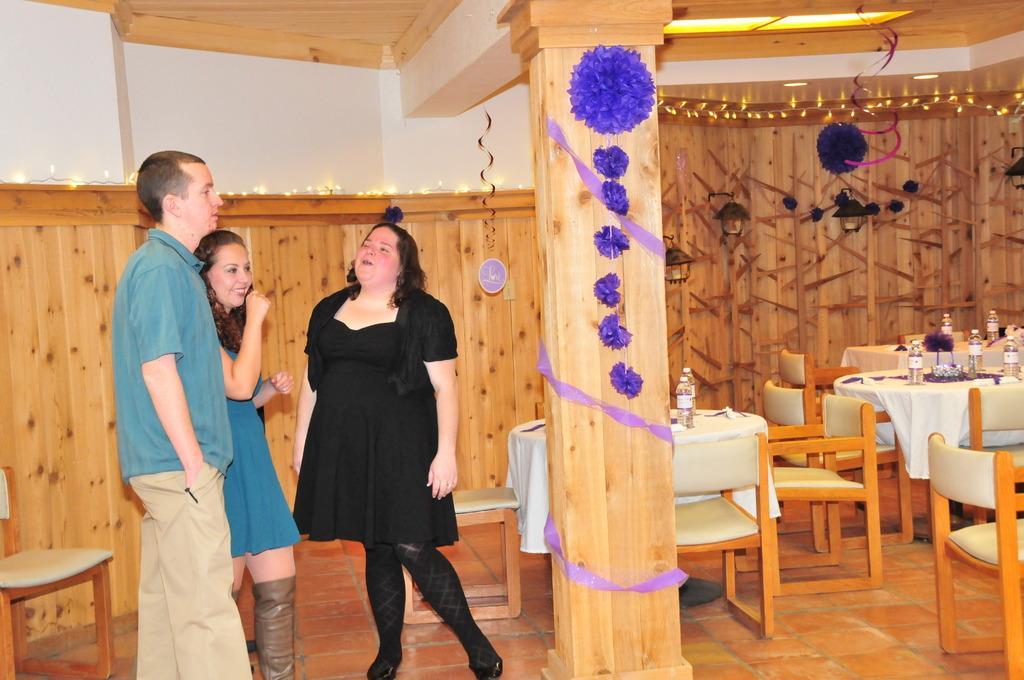Please provide a concise description of this image. In this room there are 2 women and a man on the left. We can also see water bottles,flower vase on the tables and there are chairs,decorated lights and wall also. 